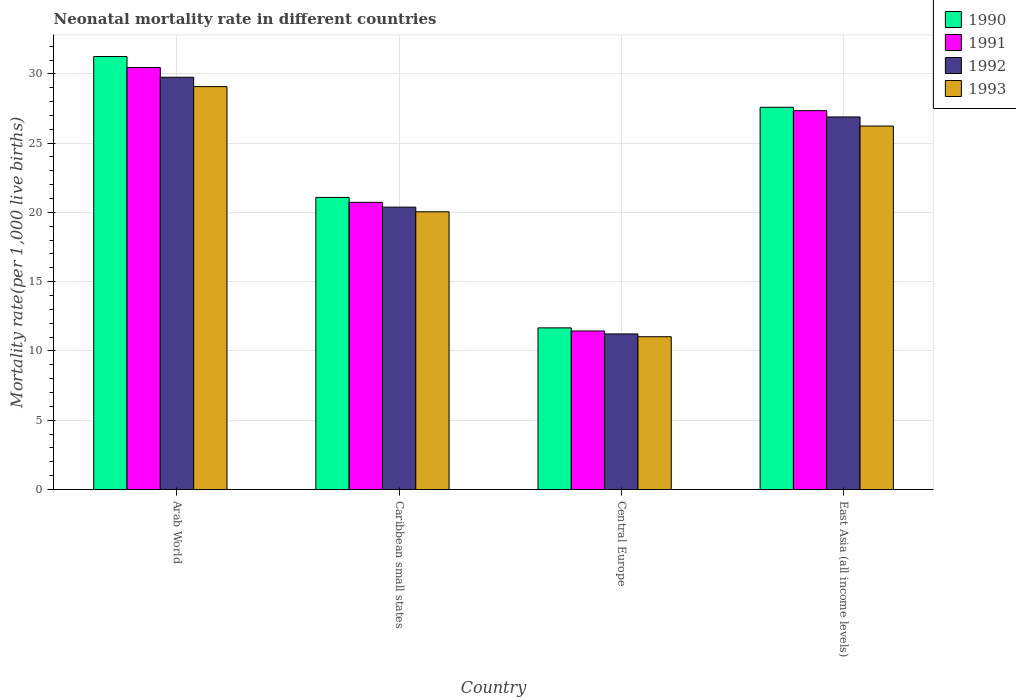How many different coloured bars are there?
Give a very brief answer. 4. Are the number of bars per tick equal to the number of legend labels?
Your answer should be compact. Yes. How many bars are there on the 3rd tick from the left?
Your response must be concise. 4. How many bars are there on the 1st tick from the right?
Keep it short and to the point. 4. What is the label of the 3rd group of bars from the left?
Provide a short and direct response. Central Europe. What is the neonatal mortality rate in 1991 in Central Europe?
Provide a short and direct response. 11.44. Across all countries, what is the maximum neonatal mortality rate in 1993?
Your response must be concise. 29.08. Across all countries, what is the minimum neonatal mortality rate in 1990?
Give a very brief answer. 11.67. In which country was the neonatal mortality rate in 1993 maximum?
Ensure brevity in your answer.  Arab World. In which country was the neonatal mortality rate in 1990 minimum?
Offer a very short reply. Central Europe. What is the total neonatal mortality rate in 1993 in the graph?
Keep it short and to the point. 86.39. What is the difference between the neonatal mortality rate in 1990 in Caribbean small states and that in Central Europe?
Your response must be concise. 9.41. What is the difference between the neonatal mortality rate in 1992 in East Asia (all income levels) and the neonatal mortality rate in 1991 in Caribbean small states?
Ensure brevity in your answer.  6.16. What is the average neonatal mortality rate in 1990 per country?
Provide a succinct answer. 22.9. What is the difference between the neonatal mortality rate of/in 1992 and neonatal mortality rate of/in 1993 in Central Europe?
Your response must be concise. 0.2. In how many countries, is the neonatal mortality rate in 1990 greater than 14?
Give a very brief answer. 3. What is the ratio of the neonatal mortality rate in 1992 in Central Europe to that in East Asia (all income levels)?
Ensure brevity in your answer.  0.42. Is the difference between the neonatal mortality rate in 1992 in Caribbean small states and Central Europe greater than the difference between the neonatal mortality rate in 1993 in Caribbean small states and Central Europe?
Offer a terse response. Yes. What is the difference between the highest and the second highest neonatal mortality rate in 1992?
Offer a terse response. 6.51. What is the difference between the highest and the lowest neonatal mortality rate in 1993?
Your response must be concise. 18.05. In how many countries, is the neonatal mortality rate in 1991 greater than the average neonatal mortality rate in 1991 taken over all countries?
Ensure brevity in your answer.  2. What does the 4th bar from the right in Central Europe represents?
Keep it short and to the point. 1990. Is it the case that in every country, the sum of the neonatal mortality rate in 1991 and neonatal mortality rate in 1990 is greater than the neonatal mortality rate in 1992?
Offer a terse response. Yes. Are all the bars in the graph horizontal?
Ensure brevity in your answer.  No. How many countries are there in the graph?
Ensure brevity in your answer.  4. Are the values on the major ticks of Y-axis written in scientific E-notation?
Give a very brief answer. No. How are the legend labels stacked?
Offer a very short reply. Vertical. What is the title of the graph?
Give a very brief answer. Neonatal mortality rate in different countries. What is the label or title of the X-axis?
Make the answer very short. Country. What is the label or title of the Y-axis?
Your answer should be very brief. Mortality rate(per 1,0 live births). What is the Mortality rate(per 1,000 live births) in 1990 in Arab World?
Keep it short and to the point. 31.25. What is the Mortality rate(per 1,000 live births) in 1991 in Arab World?
Give a very brief answer. 30.46. What is the Mortality rate(per 1,000 live births) in 1992 in Arab World?
Make the answer very short. 29.76. What is the Mortality rate(per 1,000 live births) of 1993 in Arab World?
Make the answer very short. 29.08. What is the Mortality rate(per 1,000 live births) in 1990 in Caribbean small states?
Your response must be concise. 21.08. What is the Mortality rate(per 1,000 live births) in 1991 in Caribbean small states?
Ensure brevity in your answer.  20.73. What is the Mortality rate(per 1,000 live births) in 1992 in Caribbean small states?
Offer a terse response. 20.38. What is the Mortality rate(per 1,000 live births) of 1993 in Caribbean small states?
Provide a short and direct response. 20.05. What is the Mortality rate(per 1,000 live births) in 1990 in Central Europe?
Your answer should be very brief. 11.67. What is the Mortality rate(per 1,000 live births) of 1991 in Central Europe?
Your response must be concise. 11.44. What is the Mortality rate(per 1,000 live births) in 1992 in Central Europe?
Keep it short and to the point. 11.23. What is the Mortality rate(per 1,000 live births) of 1993 in Central Europe?
Give a very brief answer. 11.03. What is the Mortality rate(per 1,000 live births) of 1990 in East Asia (all income levels)?
Your answer should be compact. 27.59. What is the Mortality rate(per 1,000 live births) of 1991 in East Asia (all income levels)?
Your answer should be compact. 27.34. What is the Mortality rate(per 1,000 live births) of 1992 in East Asia (all income levels)?
Your response must be concise. 26.89. What is the Mortality rate(per 1,000 live births) in 1993 in East Asia (all income levels)?
Your answer should be compact. 26.23. Across all countries, what is the maximum Mortality rate(per 1,000 live births) of 1990?
Your answer should be very brief. 31.25. Across all countries, what is the maximum Mortality rate(per 1,000 live births) of 1991?
Give a very brief answer. 30.46. Across all countries, what is the maximum Mortality rate(per 1,000 live births) of 1992?
Provide a short and direct response. 29.76. Across all countries, what is the maximum Mortality rate(per 1,000 live births) of 1993?
Your response must be concise. 29.08. Across all countries, what is the minimum Mortality rate(per 1,000 live births) of 1990?
Make the answer very short. 11.67. Across all countries, what is the minimum Mortality rate(per 1,000 live births) of 1991?
Offer a terse response. 11.44. Across all countries, what is the minimum Mortality rate(per 1,000 live births) of 1992?
Give a very brief answer. 11.23. Across all countries, what is the minimum Mortality rate(per 1,000 live births) of 1993?
Keep it short and to the point. 11.03. What is the total Mortality rate(per 1,000 live births) of 1990 in the graph?
Keep it short and to the point. 91.59. What is the total Mortality rate(per 1,000 live births) of 1991 in the graph?
Give a very brief answer. 89.97. What is the total Mortality rate(per 1,000 live births) of 1992 in the graph?
Offer a very short reply. 88.25. What is the total Mortality rate(per 1,000 live births) in 1993 in the graph?
Provide a short and direct response. 86.39. What is the difference between the Mortality rate(per 1,000 live births) in 1990 in Arab World and that in Caribbean small states?
Provide a short and direct response. 10.17. What is the difference between the Mortality rate(per 1,000 live births) of 1991 in Arab World and that in Caribbean small states?
Offer a terse response. 9.73. What is the difference between the Mortality rate(per 1,000 live births) in 1992 in Arab World and that in Caribbean small states?
Provide a succinct answer. 9.38. What is the difference between the Mortality rate(per 1,000 live births) in 1993 in Arab World and that in Caribbean small states?
Your answer should be compact. 9.03. What is the difference between the Mortality rate(per 1,000 live births) of 1990 in Arab World and that in Central Europe?
Ensure brevity in your answer.  19.58. What is the difference between the Mortality rate(per 1,000 live births) in 1991 in Arab World and that in Central Europe?
Your response must be concise. 19.01. What is the difference between the Mortality rate(per 1,000 live births) in 1992 in Arab World and that in Central Europe?
Offer a very short reply. 18.53. What is the difference between the Mortality rate(per 1,000 live births) of 1993 in Arab World and that in Central Europe?
Your response must be concise. 18.05. What is the difference between the Mortality rate(per 1,000 live births) of 1990 in Arab World and that in East Asia (all income levels)?
Provide a short and direct response. 3.66. What is the difference between the Mortality rate(per 1,000 live births) of 1991 in Arab World and that in East Asia (all income levels)?
Give a very brief answer. 3.11. What is the difference between the Mortality rate(per 1,000 live births) of 1992 in Arab World and that in East Asia (all income levels)?
Your response must be concise. 2.87. What is the difference between the Mortality rate(per 1,000 live births) in 1993 in Arab World and that in East Asia (all income levels)?
Offer a very short reply. 2.85. What is the difference between the Mortality rate(per 1,000 live births) of 1990 in Caribbean small states and that in Central Europe?
Your answer should be very brief. 9.41. What is the difference between the Mortality rate(per 1,000 live births) of 1991 in Caribbean small states and that in Central Europe?
Ensure brevity in your answer.  9.28. What is the difference between the Mortality rate(per 1,000 live births) of 1992 in Caribbean small states and that in Central Europe?
Ensure brevity in your answer.  9.15. What is the difference between the Mortality rate(per 1,000 live births) in 1993 in Caribbean small states and that in Central Europe?
Provide a succinct answer. 9.02. What is the difference between the Mortality rate(per 1,000 live births) of 1990 in Caribbean small states and that in East Asia (all income levels)?
Keep it short and to the point. -6.51. What is the difference between the Mortality rate(per 1,000 live births) in 1991 in Caribbean small states and that in East Asia (all income levels)?
Offer a very short reply. -6.62. What is the difference between the Mortality rate(per 1,000 live births) in 1992 in Caribbean small states and that in East Asia (all income levels)?
Your answer should be compact. -6.51. What is the difference between the Mortality rate(per 1,000 live births) of 1993 in Caribbean small states and that in East Asia (all income levels)?
Your answer should be very brief. -6.19. What is the difference between the Mortality rate(per 1,000 live births) of 1990 in Central Europe and that in East Asia (all income levels)?
Make the answer very short. -15.92. What is the difference between the Mortality rate(per 1,000 live births) in 1991 in Central Europe and that in East Asia (all income levels)?
Provide a succinct answer. -15.9. What is the difference between the Mortality rate(per 1,000 live births) in 1992 in Central Europe and that in East Asia (all income levels)?
Keep it short and to the point. -15.66. What is the difference between the Mortality rate(per 1,000 live births) in 1993 in Central Europe and that in East Asia (all income levels)?
Ensure brevity in your answer.  -15.21. What is the difference between the Mortality rate(per 1,000 live births) in 1990 in Arab World and the Mortality rate(per 1,000 live births) in 1991 in Caribbean small states?
Ensure brevity in your answer.  10.52. What is the difference between the Mortality rate(per 1,000 live births) in 1990 in Arab World and the Mortality rate(per 1,000 live births) in 1992 in Caribbean small states?
Your answer should be very brief. 10.87. What is the difference between the Mortality rate(per 1,000 live births) of 1990 in Arab World and the Mortality rate(per 1,000 live births) of 1993 in Caribbean small states?
Give a very brief answer. 11.2. What is the difference between the Mortality rate(per 1,000 live births) of 1991 in Arab World and the Mortality rate(per 1,000 live births) of 1992 in Caribbean small states?
Ensure brevity in your answer.  10.08. What is the difference between the Mortality rate(per 1,000 live births) of 1991 in Arab World and the Mortality rate(per 1,000 live births) of 1993 in Caribbean small states?
Your answer should be very brief. 10.41. What is the difference between the Mortality rate(per 1,000 live births) of 1992 in Arab World and the Mortality rate(per 1,000 live births) of 1993 in Caribbean small states?
Your answer should be compact. 9.71. What is the difference between the Mortality rate(per 1,000 live births) in 1990 in Arab World and the Mortality rate(per 1,000 live births) in 1991 in Central Europe?
Ensure brevity in your answer.  19.81. What is the difference between the Mortality rate(per 1,000 live births) in 1990 in Arab World and the Mortality rate(per 1,000 live births) in 1992 in Central Europe?
Your response must be concise. 20.02. What is the difference between the Mortality rate(per 1,000 live births) of 1990 in Arab World and the Mortality rate(per 1,000 live births) of 1993 in Central Europe?
Offer a very short reply. 20.22. What is the difference between the Mortality rate(per 1,000 live births) in 1991 in Arab World and the Mortality rate(per 1,000 live births) in 1992 in Central Europe?
Your answer should be very brief. 19.23. What is the difference between the Mortality rate(per 1,000 live births) of 1991 in Arab World and the Mortality rate(per 1,000 live births) of 1993 in Central Europe?
Keep it short and to the point. 19.43. What is the difference between the Mortality rate(per 1,000 live births) of 1992 in Arab World and the Mortality rate(per 1,000 live births) of 1993 in Central Europe?
Ensure brevity in your answer.  18.73. What is the difference between the Mortality rate(per 1,000 live births) of 1990 in Arab World and the Mortality rate(per 1,000 live births) of 1991 in East Asia (all income levels)?
Keep it short and to the point. 3.91. What is the difference between the Mortality rate(per 1,000 live births) in 1990 in Arab World and the Mortality rate(per 1,000 live births) in 1992 in East Asia (all income levels)?
Provide a succinct answer. 4.36. What is the difference between the Mortality rate(per 1,000 live births) of 1990 in Arab World and the Mortality rate(per 1,000 live births) of 1993 in East Asia (all income levels)?
Your answer should be very brief. 5.02. What is the difference between the Mortality rate(per 1,000 live births) in 1991 in Arab World and the Mortality rate(per 1,000 live births) in 1992 in East Asia (all income levels)?
Your answer should be very brief. 3.57. What is the difference between the Mortality rate(per 1,000 live births) in 1991 in Arab World and the Mortality rate(per 1,000 live births) in 1993 in East Asia (all income levels)?
Provide a short and direct response. 4.22. What is the difference between the Mortality rate(per 1,000 live births) of 1992 in Arab World and the Mortality rate(per 1,000 live births) of 1993 in East Asia (all income levels)?
Your answer should be very brief. 3.52. What is the difference between the Mortality rate(per 1,000 live births) of 1990 in Caribbean small states and the Mortality rate(per 1,000 live births) of 1991 in Central Europe?
Your answer should be very brief. 9.64. What is the difference between the Mortality rate(per 1,000 live births) of 1990 in Caribbean small states and the Mortality rate(per 1,000 live births) of 1992 in Central Europe?
Give a very brief answer. 9.85. What is the difference between the Mortality rate(per 1,000 live births) in 1990 in Caribbean small states and the Mortality rate(per 1,000 live births) in 1993 in Central Europe?
Provide a short and direct response. 10.05. What is the difference between the Mortality rate(per 1,000 live births) in 1991 in Caribbean small states and the Mortality rate(per 1,000 live births) in 1992 in Central Europe?
Offer a terse response. 9.5. What is the difference between the Mortality rate(per 1,000 live births) in 1991 in Caribbean small states and the Mortality rate(per 1,000 live births) in 1993 in Central Europe?
Offer a terse response. 9.7. What is the difference between the Mortality rate(per 1,000 live births) of 1992 in Caribbean small states and the Mortality rate(per 1,000 live births) of 1993 in Central Europe?
Offer a very short reply. 9.35. What is the difference between the Mortality rate(per 1,000 live births) in 1990 in Caribbean small states and the Mortality rate(per 1,000 live births) in 1991 in East Asia (all income levels)?
Keep it short and to the point. -6.26. What is the difference between the Mortality rate(per 1,000 live births) of 1990 in Caribbean small states and the Mortality rate(per 1,000 live births) of 1992 in East Asia (all income levels)?
Provide a short and direct response. -5.81. What is the difference between the Mortality rate(per 1,000 live births) in 1990 in Caribbean small states and the Mortality rate(per 1,000 live births) in 1993 in East Asia (all income levels)?
Give a very brief answer. -5.15. What is the difference between the Mortality rate(per 1,000 live births) in 1991 in Caribbean small states and the Mortality rate(per 1,000 live births) in 1992 in East Asia (all income levels)?
Offer a terse response. -6.16. What is the difference between the Mortality rate(per 1,000 live births) in 1991 in Caribbean small states and the Mortality rate(per 1,000 live births) in 1993 in East Asia (all income levels)?
Offer a terse response. -5.51. What is the difference between the Mortality rate(per 1,000 live births) in 1992 in Caribbean small states and the Mortality rate(per 1,000 live births) in 1993 in East Asia (all income levels)?
Give a very brief answer. -5.85. What is the difference between the Mortality rate(per 1,000 live births) in 1990 in Central Europe and the Mortality rate(per 1,000 live births) in 1991 in East Asia (all income levels)?
Offer a terse response. -15.68. What is the difference between the Mortality rate(per 1,000 live births) of 1990 in Central Europe and the Mortality rate(per 1,000 live births) of 1992 in East Asia (all income levels)?
Keep it short and to the point. -15.22. What is the difference between the Mortality rate(per 1,000 live births) of 1990 in Central Europe and the Mortality rate(per 1,000 live births) of 1993 in East Asia (all income levels)?
Your answer should be compact. -14.57. What is the difference between the Mortality rate(per 1,000 live births) of 1991 in Central Europe and the Mortality rate(per 1,000 live births) of 1992 in East Asia (all income levels)?
Provide a succinct answer. -15.45. What is the difference between the Mortality rate(per 1,000 live births) in 1991 in Central Europe and the Mortality rate(per 1,000 live births) in 1993 in East Asia (all income levels)?
Offer a very short reply. -14.79. What is the difference between the Mortality rate(per 1,000 live births) in 1992 in Central Europe and the Mortality rate(per 1,000 live births) in 1993 in East Asia (all income levels)?
Your response must be concise. -15.01. What is the average Mortality rate(per 1,000 live births) of 1990 per country?
Your answer should be very brief. 22.9. What is the average Mortality rate(per 1,000 live births) of 1991 per country?
Ensure brevity in your answer.  22.49. What is the average Mortality rate(per 1,000 live births) of 1992 per country?
Ensure brevity in your answer.  22.06. What is the average Mortality rate(per 1,000 live births) of 1993 per country?
Offer a very short reply. 21.6. What is the difference between the Mortality rate(per 1,000 live births) in 1990 and Mortality rate(per 1,000 live births) in 1991 in Arab World?
Provide a short and direct response. 0.79. What is the difference between the Mortality rate(per 1,000 live births) of 1990 and Mortality rate(per 1,000 live births) of 1992 in Arab World?
Provide a short and direct response. 1.49. What is the difference between the Mortality rate(per 1,000 live births) in 1990 and Mortality rate(per 1,000 live births) in 1993 in Arab World?
Ensure brevity in your answer.  2.17. What is the difference between the Mortality rate(per 1,000 live births) in 1991 and Mortality rate(per 1,000 live births) in 1992 in Arab World?
Give a very brief answer. 0.7. What is the difference between the Mortality rate(per 1,000 live births) in 1991 and Mortality rate(per 1,000 live births) in 1993 in Arab World?
Ensure brevity in your answer.  1.38. What is the difference between the Mortality rate(per 1,000 live births) in 1992 and Mortality rate(per 1,000 live births) in 1993 in Arab World?
Provide a short and direct response. 0.68. What is the difference between the Mortality rate(per 1,000 live births) of 1990 and Mortality rate(per 1,000 live births) of 1991 in Caribbean small states?
Your answer should be compact. 0.35. What is the difference between the Mortality rate(per 1,000 live births) in 1990 and Mortality rate(per 1,000 live births) in 1992 in Caribbean small states?
Provide a short and direct response. 0.7. What is the difference between the Mortality rate(per 1,000 live births) in 1990 and Mortality rate(per 1,000 live births) in 1993 in Caribbean small states?
Give a very brief answer. 1.04. What is the difference between the Mortality rate(per 1,000 live births) of 1991 and Mortality rate(per 1,000 live births) of 1992 in Caribbean small states?
Your answer should be compact. 0.35. What is the difference between the Mortality rate(per 1,000 live births) of 1991 and Mortality rate(per 1,000 live births) of 1993 in Caribbean small states?
Provide a succinct answer. 0.68. What is the difference between the Mortality rate(per 1,000 live births) in 1992 and Mortality rate(per 1,000 live births) in 1993 in Caribbean small states?
Your answer should be very brief. 0.33. What is the difference between the Mortality rate(per 1,000 live births) in 1990 and Mortality rate(per 1,000 live births) in 1991 in Central Europe?
Provide a short and direct response. 0.23. What is the difference between the Mortality rate(per 1,000 live births) of 1990 and Mortality rate(per 1,000 live births) of 1992 in Central Europe?
Your response must be concise. 0.44. What is the difference between the Mortality rate(per 1,000 live births) of 1990 and Mortality rate(per 1,000 live births) of 1993 in Central Europe?
Your answer should be compact. 0.64. What is the difference between the Mortality rate(per 1,000 live births) in 1991 and Mortality rate(per 1,000 live births) in 1992 in Central Europe?
Ensure brevity in your answer.  0.21. What is the difference between the Mortality rate(per 1,000 live births) of 1991 and Mortality rate(per 1,000 live births) of 1993 in Central Europe?
Give a very brief answer. 0.42. What is the difference between the Mortality rate(per 1,000 live births) of 1992 and Mortality rate(per 1,000 live births) of 1993 in Central Europe?
Provide a succinct answer. 0.2. What is the difference between the Mortality rate(per 1,000 live births) in 1990 and Mortality rate(per 1,000 live births) in 1991 in East Asia (all income levels)?
Make the answer very short. 0.24. What is the difference between the Mortality rate(per 1,000 live births) in 1990 and Mortality rate(per 1,000 live births) in 1992 in East Asia (all income levels)?
Your answer should be compact. 0.7. What is the difference between the Mortality rate(per 1,000 live births) in 1990 and Mortality rate(per 1,000 live births) in 1993 in East Asia (all income levels)?
Offer a terse response. 1.35. What is the difference between the Mortality rate(per 1,000 live births) in 1991 and Mortality rate(per 1,000 live births) in 1992 in East Asia (all income levels)?
Offer a very short reply. 0.45. What is the difference between the Mortality rate(per 1,000 live births) in 1991 and Mortality rate(per 1,000 live births) in 1993 in East Asia (all income levels)?
Give a very brief answer. 1.11. What is the difference between the Mortality rate(per 1,000 live births) of 1992 and Mortality rate(per 1,000 live births) of 1993 in East Asia (all income levels)?
Your response must be concise. 0.66. What is the ratio of the Mortality rate(per 1,000 live births) in 1990 in Arab World to that in Caribbean small states?
Provide a succinct answer. 1.48. What is the ratio of the Mortality rate(per 1,000 live births) in 1991 in Arab World to that in Caribbean small states?
Provide a short and direct response. 1.47. What is the ratio of the Mortality rate(per 1,000 live births) of 1992 in Arab World to that in Caribbean small states?
Make the answer very short. 1.46. What is the ratio of the Mortality rate(per 1,000 live births) of 1993 in Arab World to that in Caribbean small states?
Ensure brevity in your answer.  1.45. What is the ratio of the Mortality rate(per 1,000 live births) of 1990 in Arab World to that in Central Europe?
Provide a succinct answer. 2.68. What is the ratio of the Mortality rate(per 1,000 live births) of 1991 in Arab World to that in Central Europe?
Offer a very short reply. 2.66. What is the ratio of the Mortality rate(per 1,000 live births) in 1992 in Arab World to that in Central Europe?
Your answer should be compact. 2.65. What is the ratio of the Mortality rate(per 1,000 live births) in 1993 in Arab World to that in Central Europe?
Ensure brevity in your answer.  2.64. What is the ratio of the Mortality rate(per 1,000 live births) in 1990 in Arab World to that in East Asia (all income levels)?
Ensure brevity in your answer.  1.13. What is the ratio of the Mortality rate(per 1,000 live births) of 1991 in Arab World to that in East Asia (all income levels)?
Offer a terse response. 1.11. What is the ratio of the Mortality rate(per 1,000 live births) in 1992 in Arab World to that in East Asia (all income levels)?
Offer a terse response. 1.11. What is the ratio of the Mortality rate(per 1,000 live births) of 1993 in Arab World to that in East Asia (all income levels)?
Offer a terse response. 1.11. What is the ratio of the Mortality rate(per 1,000 live births) in 1990 in Caribbean small states to that in Central Europe?
Offer a very short reply. 1.81. What is the ratio of the Mortality rate(per 1,000 live births) of 1991 in Caribbean small states to that in Central Europe?
Ensure brevity in your answer.  1.81. What is the ratio of the Mortality rate(per 1,000 live births) of 1992 in Caribbean small states to that in Central Europe?
Your response must be concise. 1.81. What is the ratio of the Mortality rate(per 1,000 live births) of 1993 in Caribbean small states to that in Central Europe?
Provide a succinct answer. 1.82. What is the ratio of the Mortality rate(per 1,000 live births) of 1990 in Caribbean small states to that in East Asia (all income levels)?
Provide a succinct answer. 0.76. What is the ratio of the Mortality rate(per 1,000 live births) in 1991 in Caribbean small states to that in East Asia (all income levels)?
Give a very brief answer. 0.76. What is the ratio of the Mortality rate(per 1,000 live births) in 1992 in Caribbean small states to that in East Asia (all income levels)?
Give a very brief answer. 0.76. What is the ratio of the Mortality rate(per 1,000 live births) in 1993 in Caribbean small states to that in East Asia (all income levels)?
Offer a very short reply. 0.76. What is the ratio of the Mortality rate(per 1,000 live births) in 1990 in Central Europe to that in East Asia (all income levels)?
Keep it short and to the point. 0.42. What is the ratio of the Mortality rate(per 1,000 live births) in 1991 in Central Europe to that in East Asia (all income levels)?
Your answer should be compact. 0.42. What is the ratio of the Mortality rate(per 1,000 live births) of 1992 in Central Europe to that in East Asia (all income levels)?
Offer a very short reply. 0.42. What is the ratio of the Mortality rate(per 1,000 live births) of 1993 in Central Europe to that in East Asia (all income levels)?
Offer a terse response. 0.42. What is the difference between the highest and the second highest Mortality rate(per 1,000 live births) of 1990?
Offer a very short reply. 3.66. What is the difference between the highest and the second highest Mortality rate(per 1,000 live births) of 1991?
Offer a terse response. 3.11. What is the difference between the highest and the second highest Mortality rate(per 1,000 live births) of 1992?
Provide a short and direct response. 2.87. What is the difference between the highest and the second highest Mortality rate(per 1,000 live births) of 1993?
Your response must be concise. 2.85. What is the difference between the highest and the lowest Mortality rate(per 1,000 live births) in 1990?
Keep it short and to the point. 19.58. What is the difference between the highest and the lowest Mortality rate(per 1,000 live births) in 1991?
Make the answer very short. 19.01. What is the difference between the highest and the lowest Mortality rate(per 1,000 live births) in 1992?
Offer a terse response. 18.53. What is the difference between the highest and the lowest Mortality rate(per 1,000 live births) of 1993?
Your answer should be very brief. 18.05. 